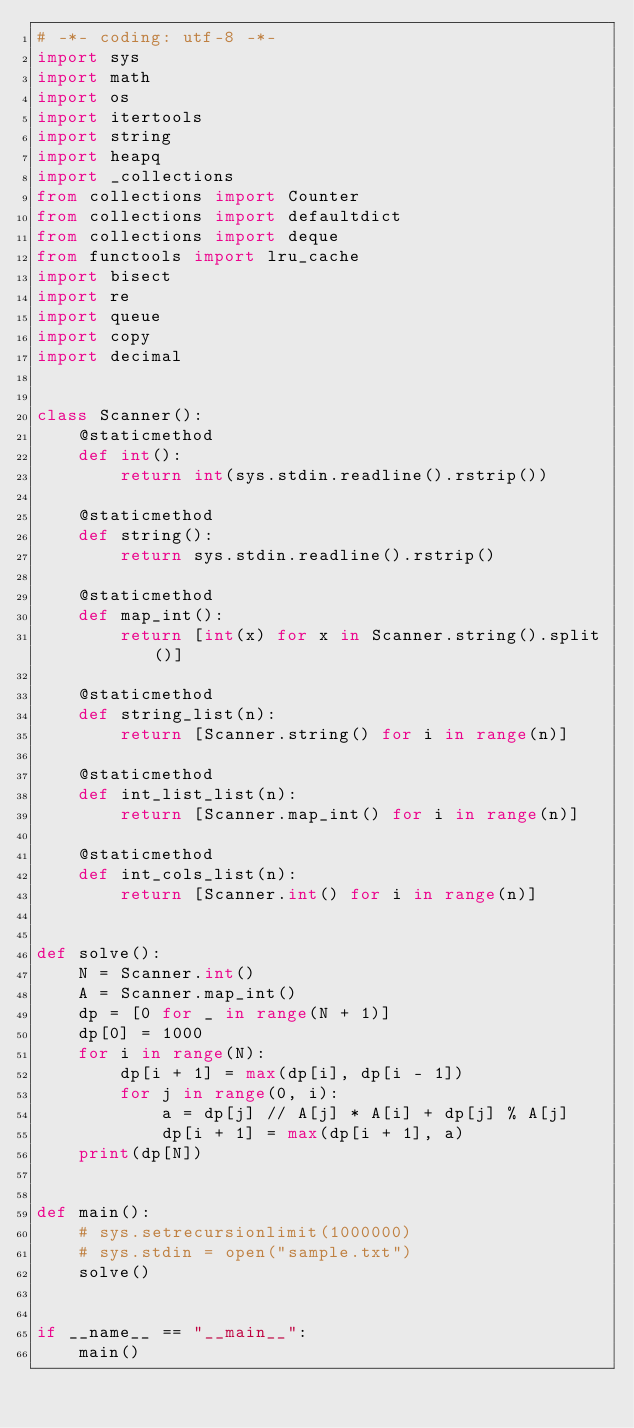<code> <loc_0><loc_0><loc_500><loc_500><_Python_># -*- coding: utf-8 -*-
import sys
import math
import os
import itertools
import string
import heapq
import _collections
from collections import Counter
from collections import defaultdict
from collections import deque
from functools import lru_cache
import bisect
import re
import queue
import copy
import decimal


class Scanner():
    @staticmethod
    def int():
        return int(sys.stdin.readline().rstrip())

    @staticmethod
    def string():
        return sys.stdin.readline().rstrip()

    @staticmethod
    def map_int():
        return [int(x) for x in Scanner.string().split()]

    @staticmethod
    def string_list(n):
        return [Scanner.string() for i in range(n)]

    @staticmethod
    def int_list_list(n):
        return [Scanner.map_int() for i in range(n)]

    @staticmethod
    def int_cols_list(n):
        return [Scanner.int() for i in range(n)]


def solve():
    N = Scanner.int()
    A = Scanner.map_int()
    dp = [0 for _ in range(N + 1)]
    dp[0] = 1000
    for i in range(N):
        dp[i + 1] = max(dp[i], dp[i - 1])
        for j in range(0, i):
            a = dp[j] // A[j] * A[i] + dp[j] % A[j]
            dp[i + 1] = max(dp[i + 1], a)
    print(dp[N])


def main():
    # sys.setrecursionlimit(1000000)
    # sys.stdin = open("sample.txt")
    solve()


if __name__ == "__main__":
    main()
</code> 